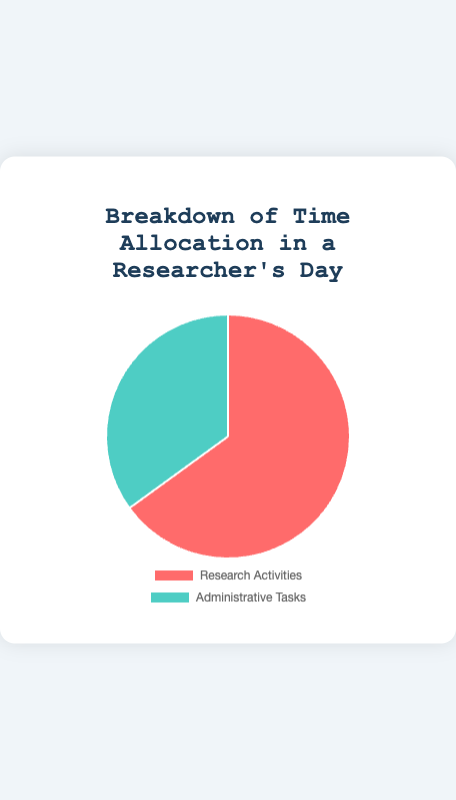What's the percentage of time allocated to research activities in a researcher's day? To find the percentage of time allocated to research activities, refer to the chart segment labeled "Research Activities" and read the associated percentage.
Answer: 65% What's the percentage of time allocated to administrative tasks in a researcher's day? To find the percentage of time allocated to administrative tasks, refer to the chart segment labeled "Administrative Tasks" and read the associated percentage.
Answer: 35% Which activity takes up a larger portion of a researcher's day, research activities or administrative tasks? Compare the percentages for "Research Activities" (65%) and "Administrative Tasks" (35%). The larger value indicates the activity that occupies more time.
Answer: Research activities By how many percentage points does the time spent on research activities exceed that spent on administrative tasks? Subtract the percentage of time spent on administrative tasks (35%) from the percentage of time spent on research activities (65%).
Answer: 30 percentage points If a researcher's workday is 10 hours long, how many hours are spent on research activities and administrative tasks respectively? Calculate the number of hours for each activity by using the percentages: Research Activities: 65% of 10 hours = 0.65 * 10 = 6.5 hours. Administrative Tasks: 35% of 10 hours = 0.35 * 10 = 3.5 hours.
Answer: 6.5 hours on research activities, 3.5 hours on administrative tasks What proportion of the pie chart does the "Administrative Tasks" segment represent visually? Visually estimate the "Administrative Tasks" segment, which is represented by 35% of the pie chart. Since a full circle is 100%, the "Administrative Tasks" segment takes up a little more than one-third of the pie.
Answer: A little more than one-third If the time allocation for research activities were to increase by 10%, what would be the new percentage for research activities and administrative tasks? If research activities increase by 10%, their new percentage would be 65% + 10% = 75%. Since the total must remain 100%, the administrative tasks percentage would decrease by 10%, making it 35% - 10% = 25%.
Answer: Research activities: 75%, Administrative tasks: 25% What is the difference in the pie chart colors representing research activities and administrative tasks? Refer to the colors used for each segment of the pie chart: "Research Activities" is represented by a shade of red, while "Administrative Tasks" is represented by a shade of green.
Answer: Red and green What percentage of the total day is not dedicated to research activities? Subtract the percentage of time spent on research activities (65%) from 100% to find the percentage of time allocated to other activities, specifically administrative tasks in this case.
Answer: 35% 